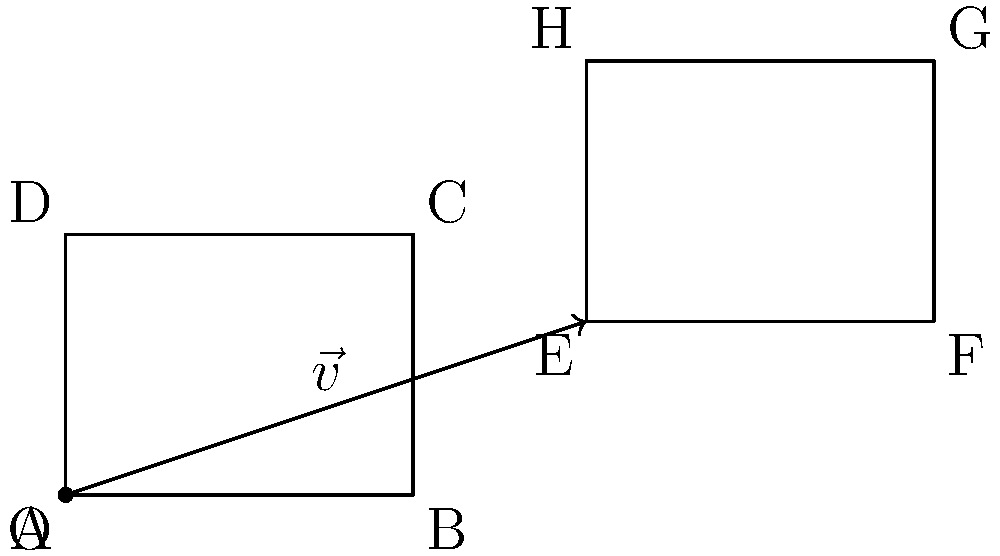As a writer inspired by Daniel Chidiac's transformative works, you're exploring the concept of translating ideas in both literature and mathematics. Consider a manuscript page represented by rectangle $ABCD$ in the coordinate plane. If you translate this page along vector $\vec{v} = \langle 6, 2 \rangle$, resulting in the new position $EFGH$, what are the coordinates of point $G$? To find the coordinates of point $G$ after translation, we can follow these steps:

1. Identify the original coordinates of point $C$, which corresponds to $G$ before translation:
   $C = (4, 3)$

2. Recall the translation vector:
   $\vec{v} = \langle 6, 2 \rangle$

3. Apply the translation to point $C$ by adding the components of $\vec{v}$:
   $G_x = C_x + v_x = 4 + 6 = 10$
   $G_y = C_y + v_y = 3 + 2 = 5$

4. Combine the new coordinates:
   $G = (10, 5)$

This process is analogous to how ideas in literature can be "translated" or transformed while maintaining their core essence, much like how Chidiac's work often encourages personal transformation while preserving one's authentic self.
Answer: $(10, 5)$ 